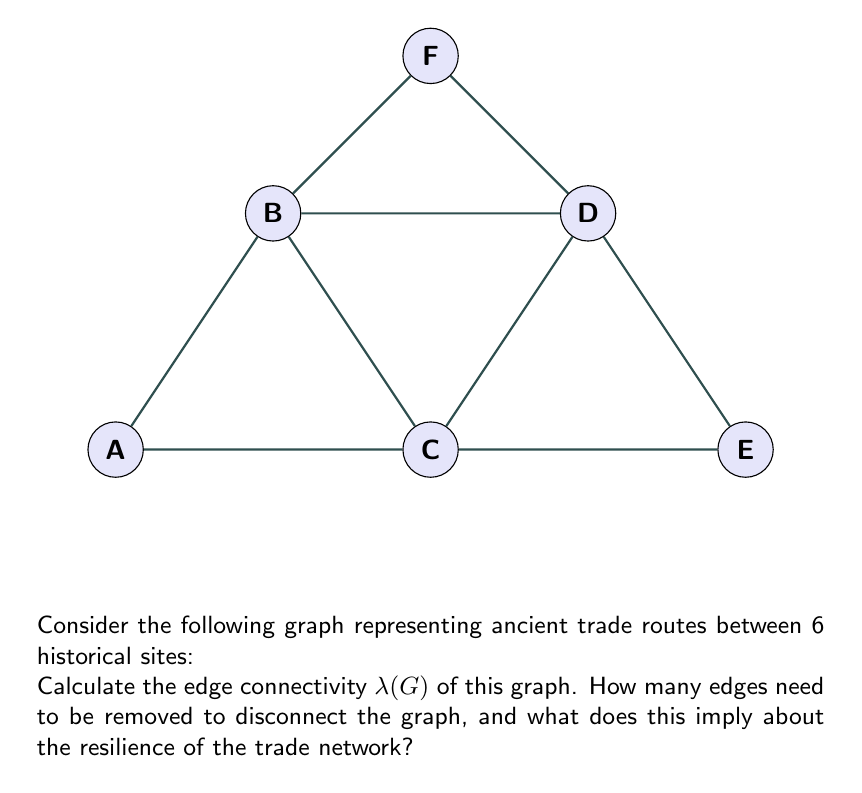Can you solve this math problem? To find the edge connectivity $\lambda(G)$ of the graph, we need to determine the minimum number of edges that, when removed, will disconnect the graph. Let's approach this step-by-step:

1) First, observe that the graph is connected, as there is a path between any pair of vertices.

2) To disconnect the graph, we need to isolate at least one vertex or split the graph into two or more components.

3) Let's examine each vertex:
   - Vertex A has degree 2
   - Vertices B, C, D, and E have degree 4
   - Vertex F has degree 2

4) The vertices with the lowest degree (A and F) are the most vulnerable. Removing the two edges connected to either A or F would disconnect the graph.

5) For any other vertex, we would need to remove at least 3 edges to isolate it.

6) To split the graph without isolating a single vertex, we would need to remove at least 3 edges. For example, removing the edges AB, BC, and CD would split the graph into two components.

7) Therefore, the minimum number of edges that need to be removed to disconnect the graph is 2.

8) By definition, the edge connectivity $\lambda(G)$ is equal to this minimum number.

9) Regarding the resilience of the trade network, this implies that the network is relatively vulnerable. The loss of just two trade routes could potentially isolate a historical site from the rest of the network.
Answer: $\lambda(G) = 2$ 